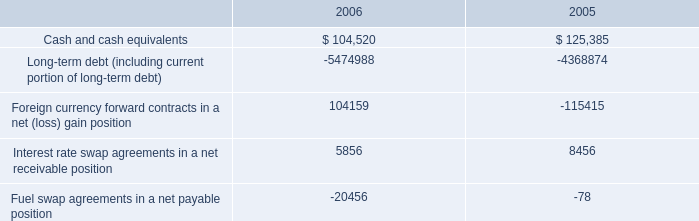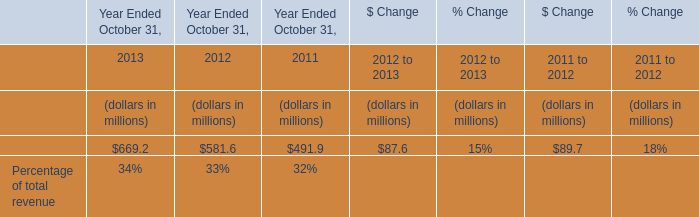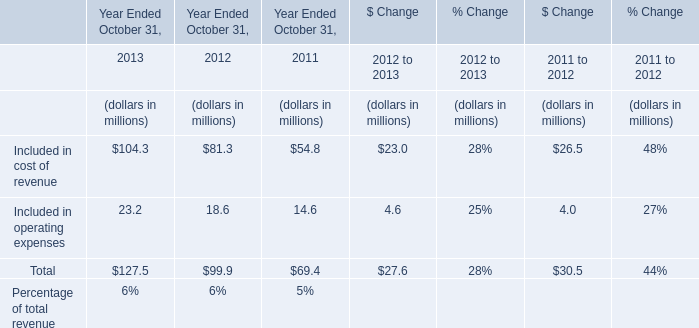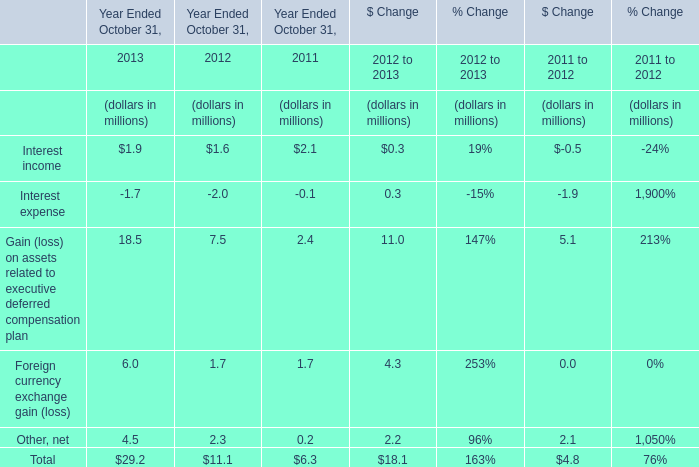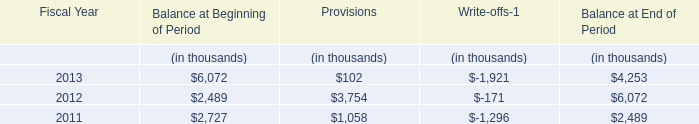what was the percentage increase in the annual pension costs from 2005 to 2006 
Computations: ((13.9 - 12.2) / 12.2)
Answer: 0.13934. 